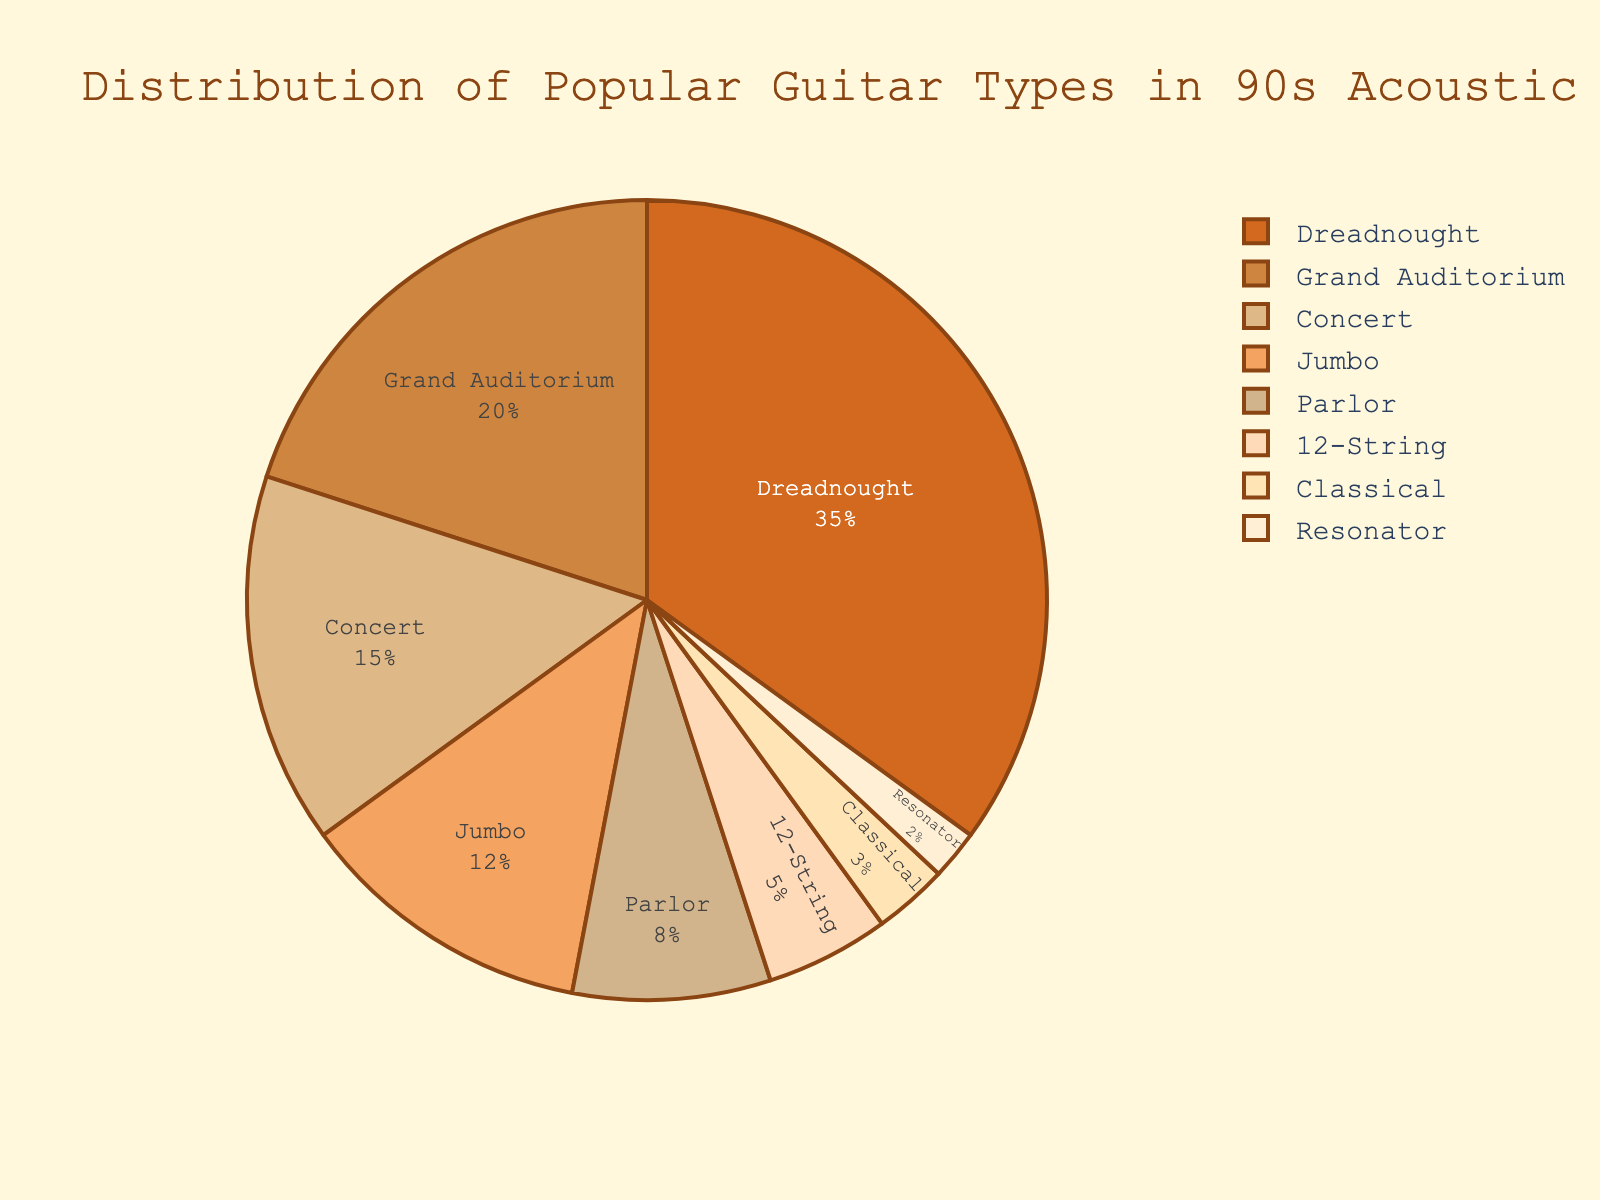What guitar type has the highest percentage? The largest section of the pie chart represents the Dreadnought, indicating it has the highest percentage at 35%.
Answer: Dreadnought Which two guitar types combined make up less than 10% of the total? The pie chart shows that 12-String has 5%, Classical has 3%, and Resonator has 2%. Combining Classical and Resonator gives 3% + 2% = 5%, which is less than 10%.
Answer: Classical and Resonator What is the difference in percentage between the Dreadnought and the Grand Auditorium guitar types? The Dreadnought section is 35% and the Grand Auditorium section is 20%. Subtracting these gives 35% - 20% = 15%.
Answer: 15% What percentage of the total is made up by the three smallest categories combined? The pie chart shows that Classical is 3%, Resonator is 2%, and 12-String is 5%. Summing these, 3% + 2% + 5% = 10%.
Answer: 10% Which guitar type makes up slightly more than half of the Grand Auditorium's percentage? The Grand Auditorium makes up 20%. Half of this is 20% / 2 = 10%. The pie chart indicates that Parlor, which makes up 8%, is slightly more than half of 20%.
Answer: Parlor What is the combined percentage of Dreadnought, Concert, and Jumbo guitar types? The pie chart shows Dreadnought at 35%, Concert at 15%, and Jumbo at 12%. Summing these, 35% + 15% + 12% = 62%.
Answer: 62% Which guitar type added to Parlor makes up a quarter of the total percentage? Parlor has 8%. We need to find a guitar type where 8% + x% = 25%. Solving this, x% = 25% - 8% = 17%. The closest matching guitar type is Grand Auditorium, at 20%. Since 17% is closest, this guitar type can approximate our solution for visual purposes.
Answer: Grand Auditorium What is the visual difference between the largest slice and the smallest slice on the pie chart? The largest slice is Dreadnought at 35%, and the smallest is Resonator at 2%. Visually, the Dreadnought section is significantly larger and stands out more than the small sliver representing the Resonator section.
Answer: Dreadnought is significantly larger than Resonator Which guitar type percentages add up to the same as the sum of Concert and Jumbo guitar types? The pie chart shows Concert at 15% and Jumbo at 12%, summing to 27%. Dreadnought (35%) - Grand Auditorium (20%) = 15%. Classicial and Parlor combined would give us 3% + 8% = 11%. Considering various combinations, Grand Auditorium + Parlor = 20% + 8%. Thus, we get the required sum by combining these with Dreadnought for visual purposes.
Answer: Grand Auditorium and Parlor 